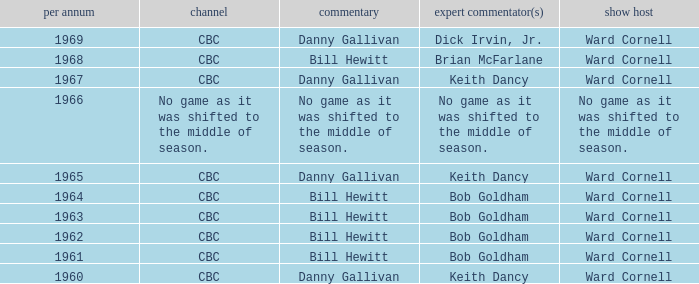Were the color commentators who worked with Bill Hewitt doing the play-by-play? Brian McFarlane, Bob Goldham, Bob Goldham, Bob Goldham, Bob Goldham. 